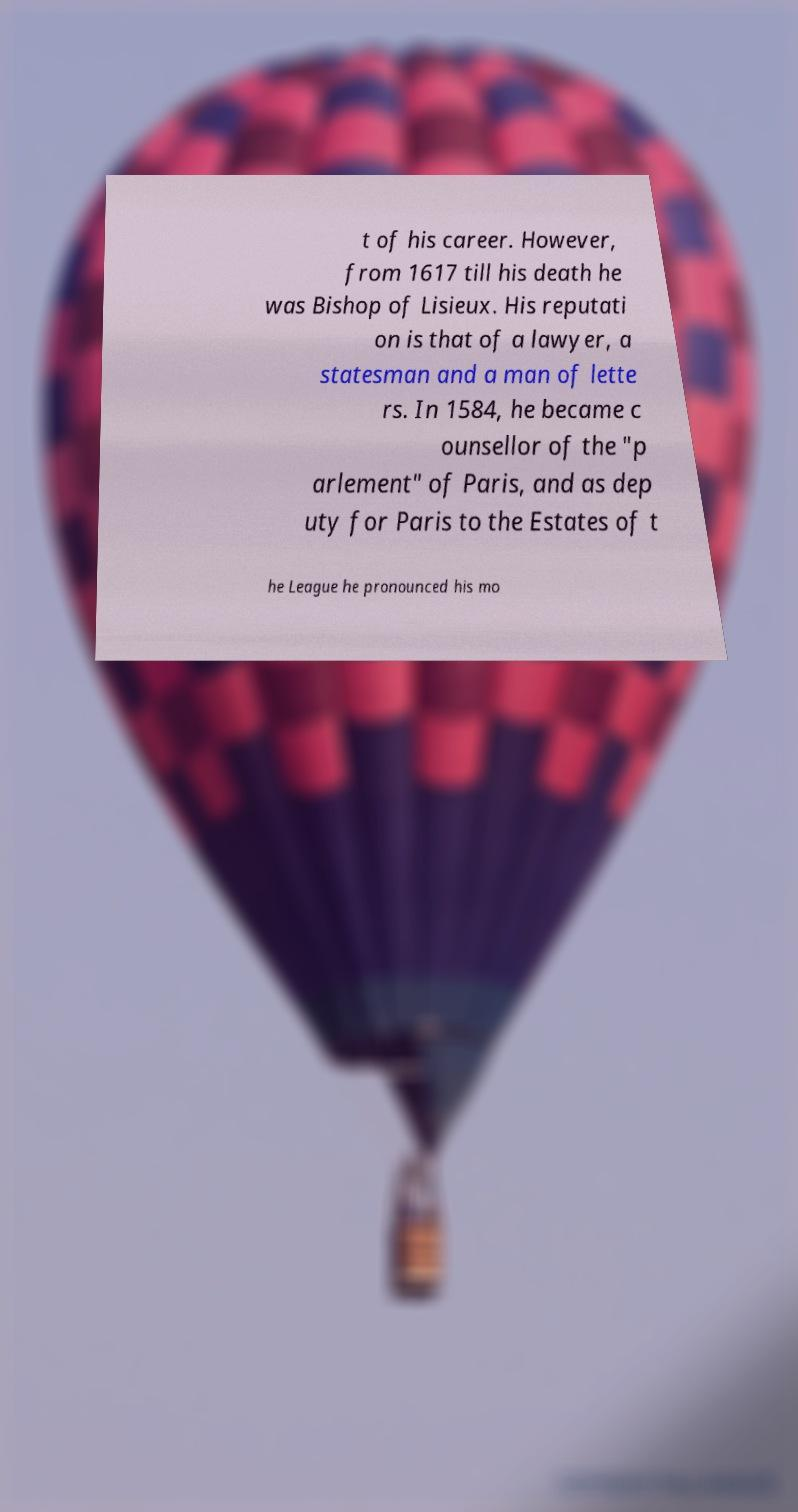Could you assist in decoding the text presented in this image and type it out clearly? t of his career. However, from 1617 till his death he was Bishop of Lisieux. His reputati on is that of a lawyer, a statesman and a man of lette rs. In 1584, he became c ounsellor of the "p arlement" of Paris, and as dep uty for Paris to the Estates of t he League he pronounced his mo 